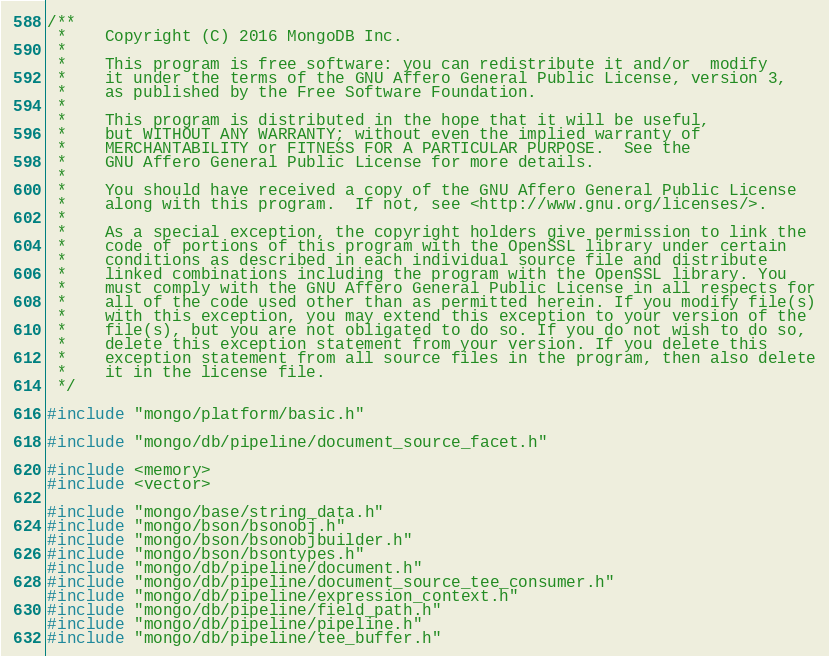Convert code to text. <code><loc_0><loc_0><loc_500><loc_500><_C++_>/**
 *    Copyright (C) 2016 MongoDB Inc.
 *
 *    This program is free software: you can redistribute it and/or  modify
 *    it under the terms of the GNU Affero General Public License, version 3,
 *    as published by the Free Software Foundation.
 *
 *    This program is distributed in the hope that it will be useful,
 *    but WITHOUT ANY WARRANTY; without even the implied warranty of
 *    MERCHANTABILITY or FITNESS FOR A PARTICULAR PURPOSE.  See the
 *    GNU Affero General Public License for more details.
 *
 *    You should have received a copy of the GNU Affero General Public License
 *    along with this program.  If not, see <http://www.gnu.org/licenses/>.
 *
 *    As a special exception, the copyright holders give permission to link the
 *    code of portions of this program with the OpenSSL library under certain
 *    conditions as described in each individual source file and distribute
 *    linked combinations including the program with the OpenSSL library. You
 *    must comply with the GNU Affero General Public License in all respects for
 *    all of the code used other than as permitted herein. If you modify file(s)
 *    with this exception, you may extend this exception to your version of the
 *    file(s), but you are not obligated to do so. If you do not wish to do so,
 *    delete this exception statement from your version. If you delete this
 *    exception statement from all source files in the program, then also delete
 *    it in the license file.
 */

#include "mongo/platform/basic.h"

#include "mongo/db/pipeline/document_source_facet.h"

#include <memory>
#include <vector>

#include "mongo/base/string_data.h"
#include "mongo/bson/bsonobj.h"
#include "mongo/bson/bsonobjbuilder.h"
#include "mongo/bson/bsontypes.h"
#include "mongo/db/pipeline/document.h"
#include "mongo/db/pipeline/document_source_tee_consumer.h"
#include "mongo/db/pipeline/expression_context.h"
#include "mongo/db/pipeline/field_path.h"
#include "mongo/db/pipeline/pipeline.h"
#include "mongo/db/pipeline/tee_buffer.h"</code> 